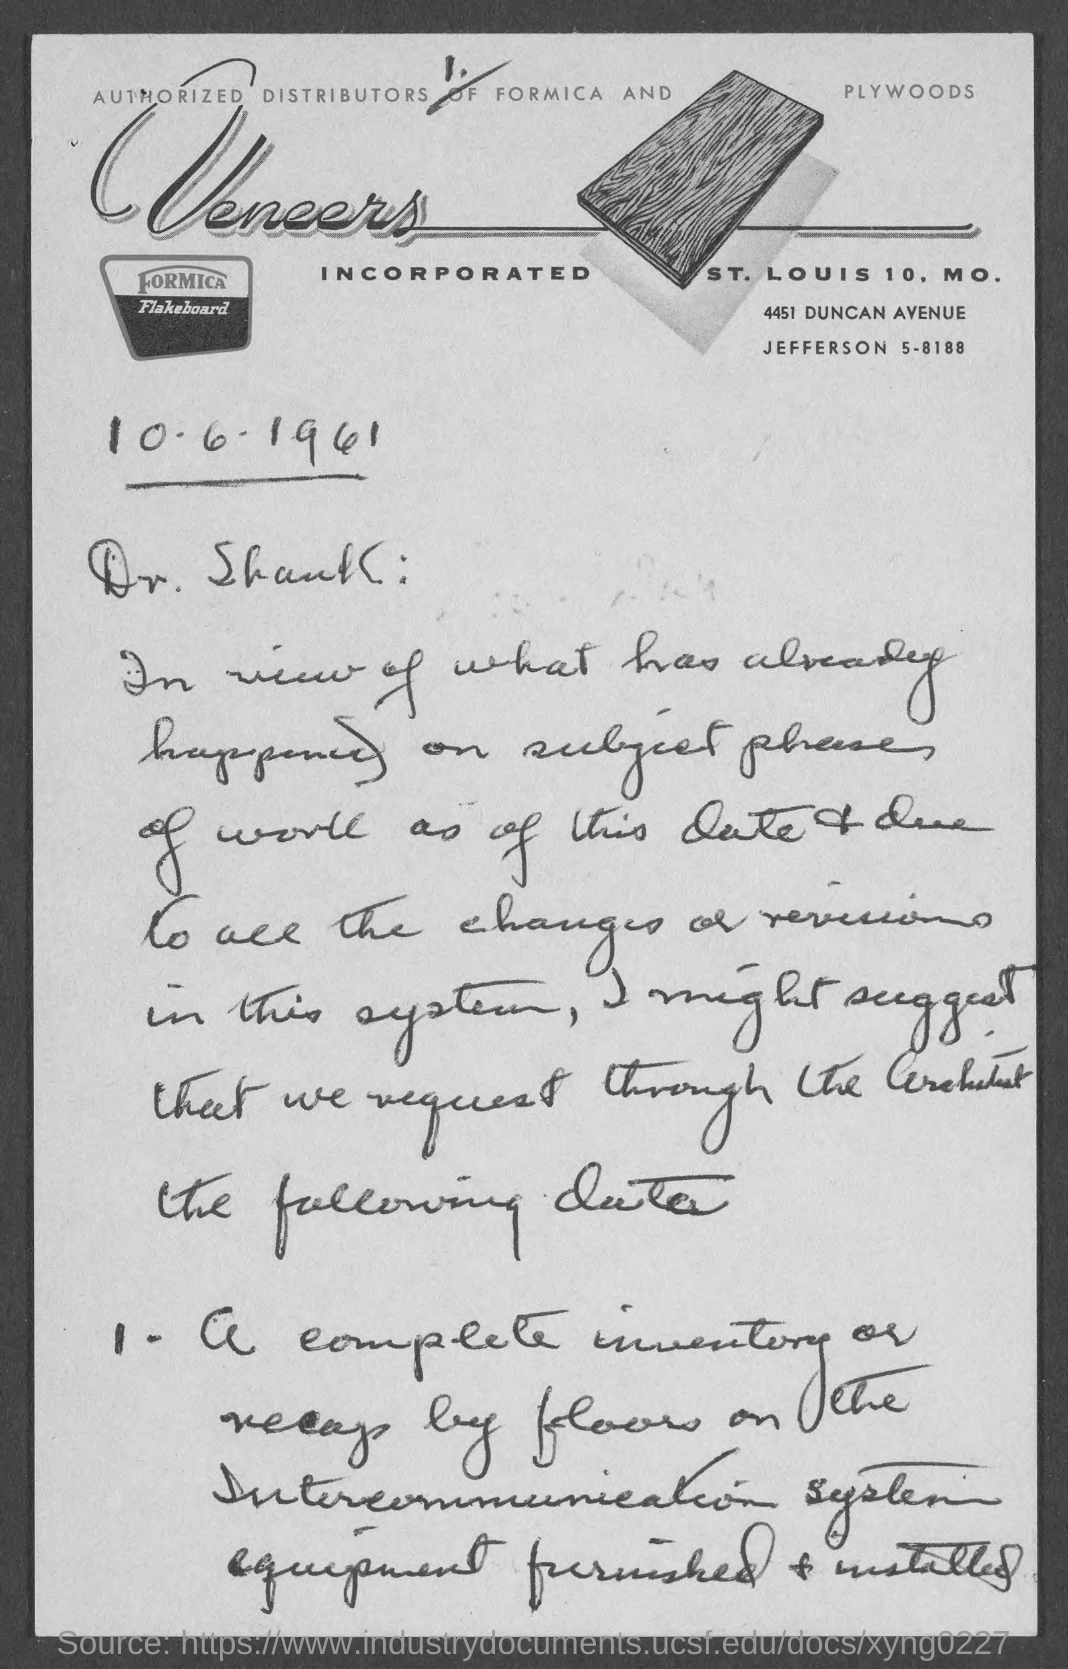To whom is this document addressed?
Make the answer very short. Dr. Shank. 